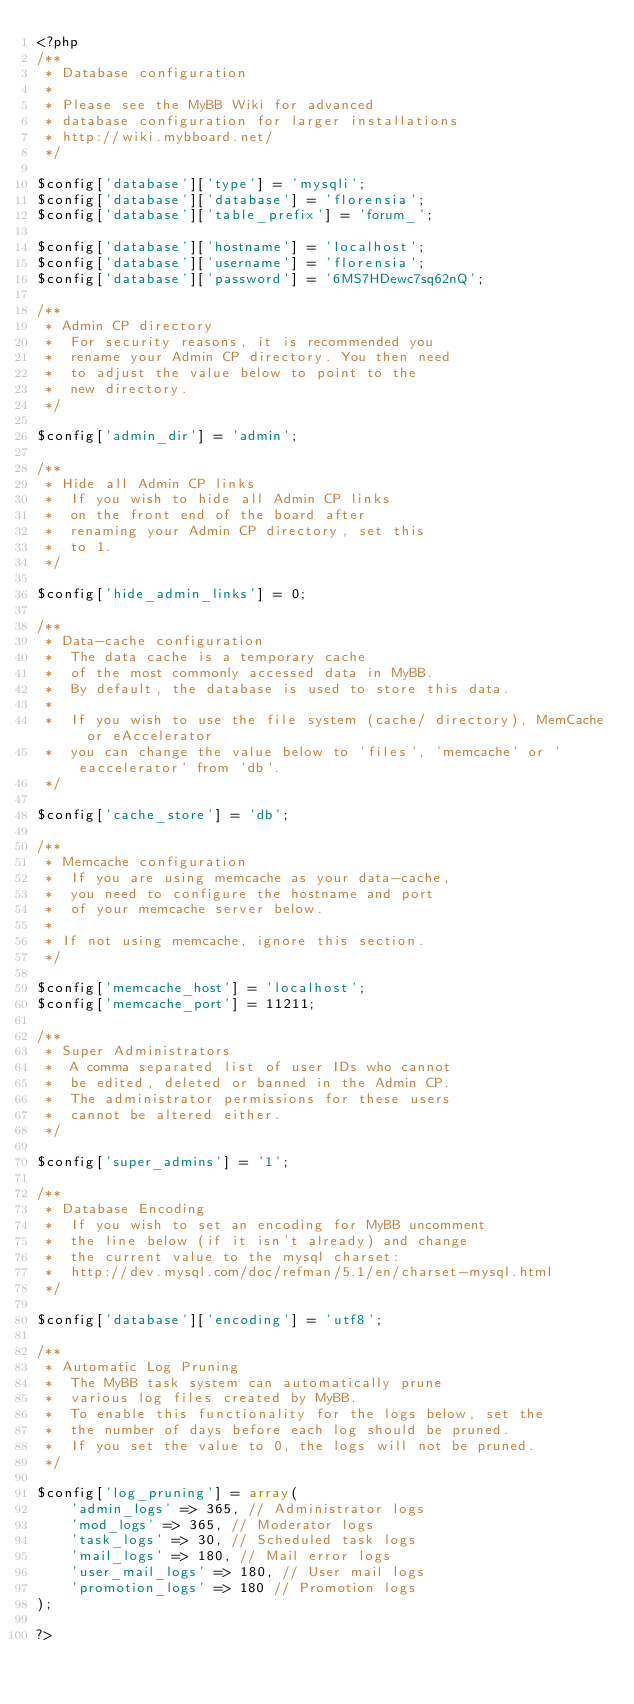<code> <loc_0><loc_0><loc_500><loc_500><_PHP_><?php
/**
 * Database configuration
 *
 * Please see the MyBB Wiki for advanced
 * database configuration for larger installations
 * http://wiki.mybboard.net/
 */

$config['database']['type'] = 'mysqli';
$config['database']['database'] = 'florensia';
$config['database']['table_prefix'] = 'forum_';

$config['database']['hostname'] = 'localhost';
$config['database']['username'] = 'florensia';
$config['database']['password'] = '6MS7HDewc7sq62nQ';

/**
 * Admin CP directory
 *  For security reasons, it is recommended you
 *  rename your Admin CP directory. You then need
 *  to adjust the value below to point to the
 *  new directory.
 */

$config['admin_dir'] = 'admin';

/**
 * Hide all Admin CP links
 *  If you wish to hide all Admin CP links
 *  on the front end of the board after
 *  renaming your Admin CP directory, set this
 *  to 1.
 */

$config['hide_admin_links'] = 0;

/**
 * Data-cache configuration
 *  The data cache is a temporary cache
 *  of the most commonly accessed data in MyBB.
 *  By default, the database is used to store this data.
 *
 *  If you wish to use the file system (cache/ directory), MemCache or eAccelerator
 *  you can change the value below to 'files', 'memcache' or 'eaccelerator' from 'db'.
 */

$config['cache_store'] = 'db';

/**
 * Memcache configuration
 *  If you are using memcache as your data-cache,
 *  you need to configure the hostname and port
 *  of your memcache server below.
 *
 * If not using memcache, ignore this section.
 */

$config['memcache_host'] = 'localhost';
$config['memcache_port'] = 11211;

/**
 * Super Administrators
 *  A comma separated list of user IDs who cannot
 *  be edited, deleted or banned in the Admin CP.
 *  The administrator permissions for these users
 *  cannot be altered either.
 */

$config['super_admins'] = '1';

/**
 * Database Encoding
 *  If you wish to set an encoding for MyBB uncomment 
 *  the line below (if it isn't already) and change
 *  the current value to the mysql charset:
 *  http://dev.mysql.com/doc/refman/5.1/en/charset-mysql.html
 */

$config['database']['encoding'] = 'utf8';

/**
 * Automatic Log Pruning
 *  The MyBB task system can automatically prune
 *  various log files created by MyBB.
 *  To enable this functionality for the logs below, set the
 *  the number of days before each log should be pruned.
 *  If you set the value to 0, the logs will not be pruned.
 */

$config['log_pruning'] = array(
	'admin_logs' => 365, // Administrator logs
	'mod_logs' => 365, // Moderator logs
	'task_logs' => 30, // Scheduled task logs
	'mail_logs' => 180, // Mail error logs
	'user_mail_logs' => 180, // User mail logs
	'promotion_logs' => 180 // Promotion logs
);
 
?>
</code> 